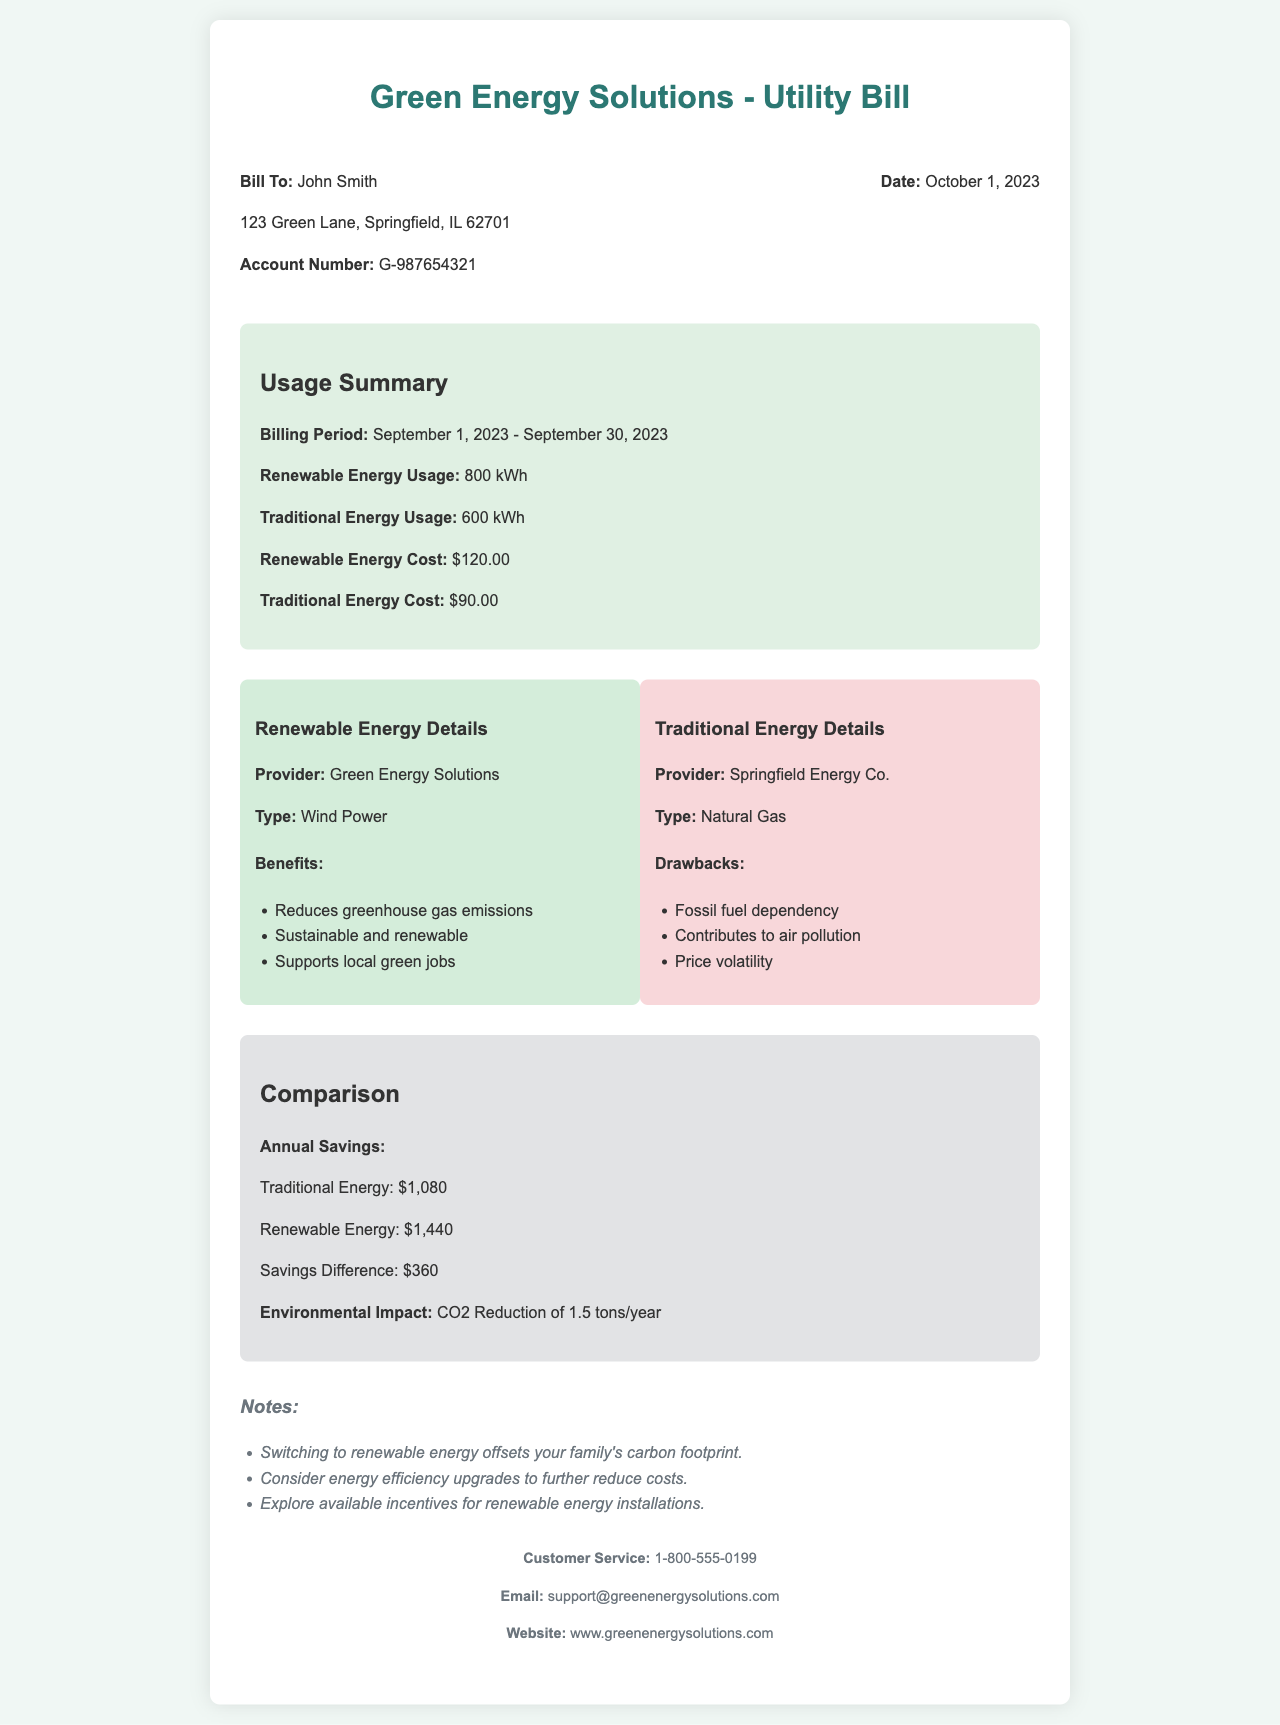What is the billing period? The billing period is stated as September 1, 2023 - September 30, 2023.
Answer: September 1, 2023 - September 30, 2023 How much renewable energy was used? The document specifies that the renewable energy usage was 800 kWh.
Answer: 800 kWh What is the cost of traditional energy? The cost of traditional energy is mentioned as $90.00.
Answer: $90.00 What is the CO2 reduction per year? The document states a CO2 reduction of 1.5 tons/year.
Answer: 1.5 tons/year Which type of renewable energy is used? The document indicates that the type of renewable energy is Wind Power.
Answer: Wind Power What is the savings difference? The savings difference between renewable and traditional energy is mentioned as $360.
Answer: $360 Who is the provider of traditional energy? The provider of traditional energy is listed as Springfield Energy Co.
Answer: Springfield Energy Co List one benefit of renewable energy. The document lists benefits of renewable energy, one of which is reducing greenhouse gas emissions.
Answer: Reduces greenhouse gas emissions What is the total renewable energy cost? The total cost for renewable energy is specified as $120.00.
Answer: $120.00 